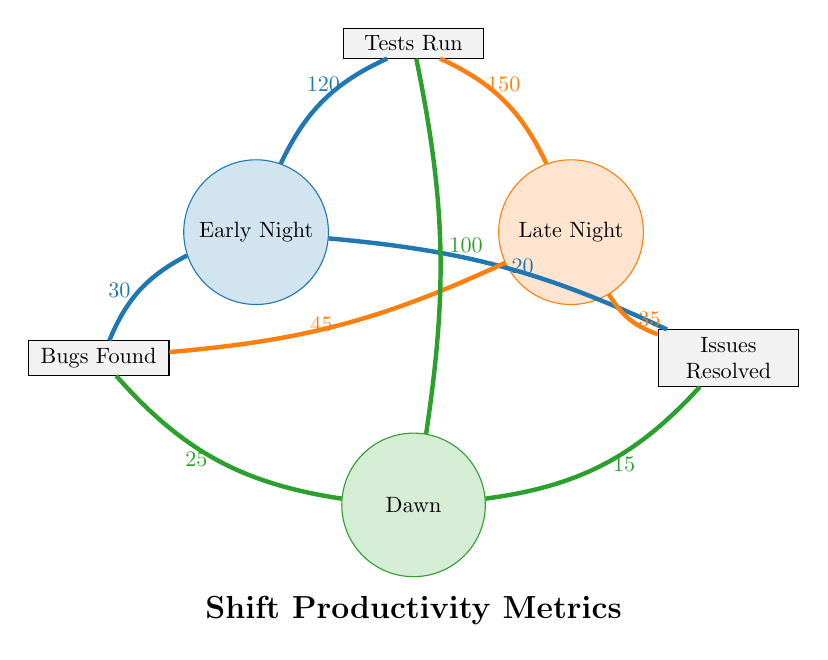What is the number of tests run during the Late Night shift? The chord connecting the Late Night shift to the Tests Run metric indicates a value of 150.
Answer: 150 Which shift found the most bugs? By comparing the chords connected to the Bugs Found metric, Late Night has the highest value of 45.
Answer: Late Night What is the total number of issues resolved across all shifts? The total can be calculated by adding the values of issues resolved for each shift: 20 (Early Night) + 35 (Late Night) + 15 (Dawn) = 70.
Answer: 70 How many tests were run during the Dawn shift? The connection from the Dawn shift to the Tests Run metric shows a value of 100.
Answer: 100 Which shift had the least number of issues resolved? Looking at the Issues Resolved connections, Dawn has the smallest value of 15.
Answer: Dawn What relationship does the Early Night shift have with the Bugs Found metric? The chord from Early Night to Bugs Found indicates that this shift found 30 bugs.
Answer: 30 What is the difference in the number of tests run between Late Night and Dawn shifts? The Tests Run values are 150 (Late Night) and 100 (Dawn). The difference is 150 - 100 = 50.
Answer: 50 Which shift had the least tests run? Among the shifts, Dawn has the lowest Tests Run value of 100 compared to Early Night 120 and Late Night 150.
Answer: Dawn Based on the diagram, how many bugs were found during the Early Night shift? The chord linking Early Night to Bugs Found indicates that this shift found 30 bugs.
Answer: 30 